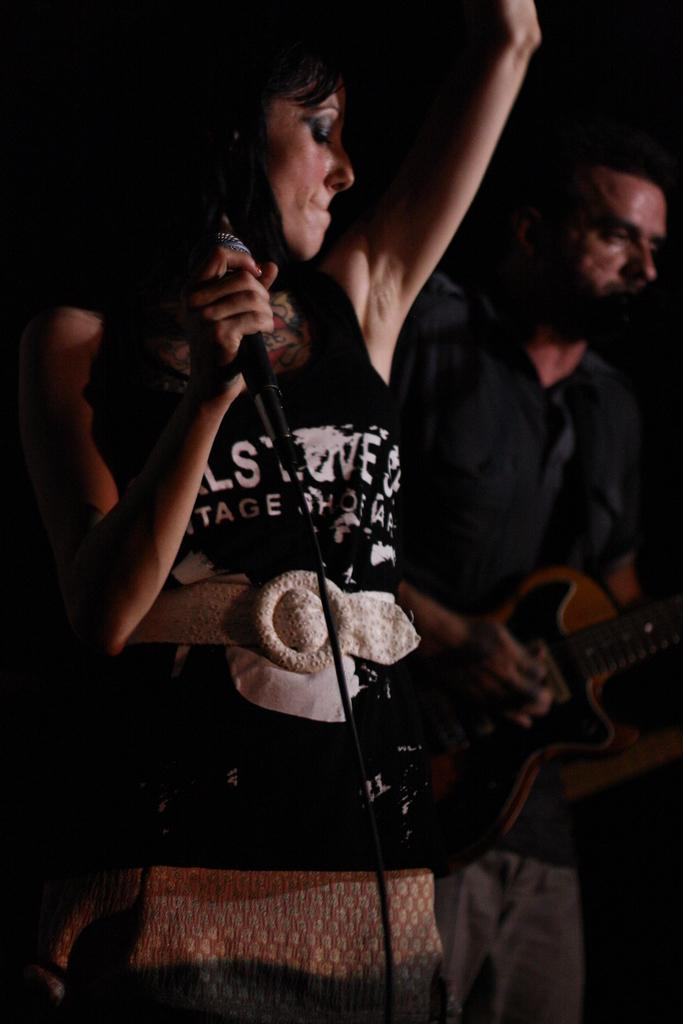Who are the people in the image? There is a woman and a man in the image. What is the man doing in the image? The man is holding a guitar and playing it. What is the woman holding in the image? The woman is holding a microphone. What type of chess pieces can be seen on the table in the image? There is no chess set or pieces present in the image. What is the relationship between the man and the woman in the image? The provided facts do not give any information about the relationship between the man and the woman in the image. 